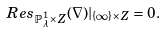Convert formula to latex. <formula><loc_0><loc_0><loc_500><loc_500>R e s _ { \mathbb { P } ^ { 1 } _ { \lambda } \times Z } ( \nabla ) | _ { \{ \infty \} \times Z } = 0 .</formula> 